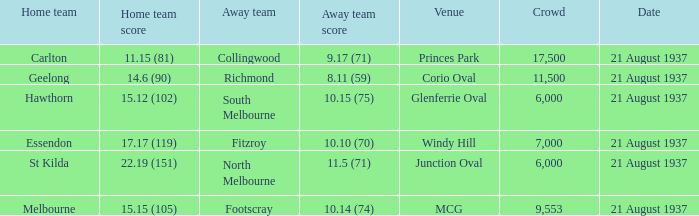At what venue do south melbourne teams compete? Glenferrie Oval. 